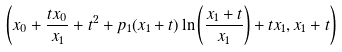<formula> <loc_0><loc_0><loc_500><loc_500>\left ( x _ { 0 } + \frac { t x _ { 0 } } { x _ { 1 } } + t ^ { 2 } + p _ { 1 } ( x _ { 1 } + t ) \ln \left ( \frac { x _ { 1 } + t } { x _ { 1 } } \right ) + t x _ { 1 } , x _ { 1 } + t \right )</formula> 